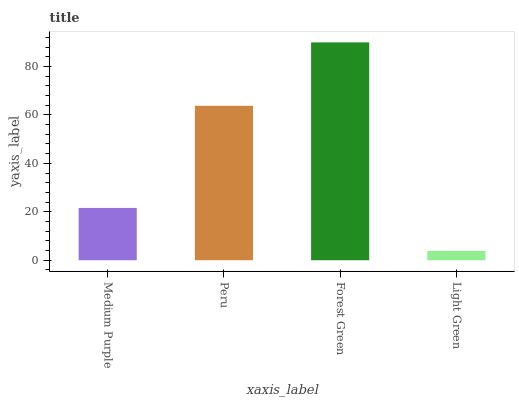Is Peru the minimum?
Answer yes or no. No. Is Peru the maximum?
Answer yes or no. No. Is Peru greater than Medium Purple?
Answer yes or no. Yes. Is Medium Purple less than Peru?
Answer yes or no. Yes. Is Medium Purple greater than Peru?
Answer yes or no. No. Is Peru less than Medium Purple?
Answer yes or no. No. Is Peru the high median?
Answer yes or no. Yes. Is Medium Purple the low median?
Answer yes or no. Yes. Is Medium Purple the high median?
Answer yes or no. No. Is Light Green the low median?
Answer yes or no. No. 